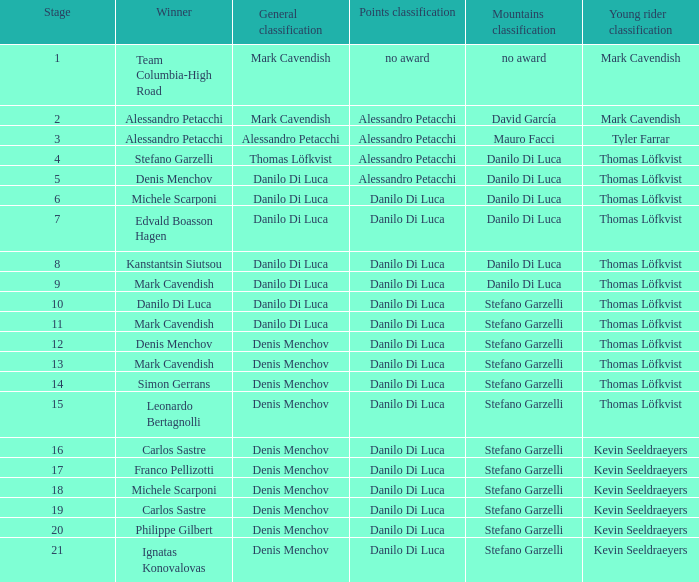If philippe gilbert wins, who clinches the points classification? Danilo Di Luca. 